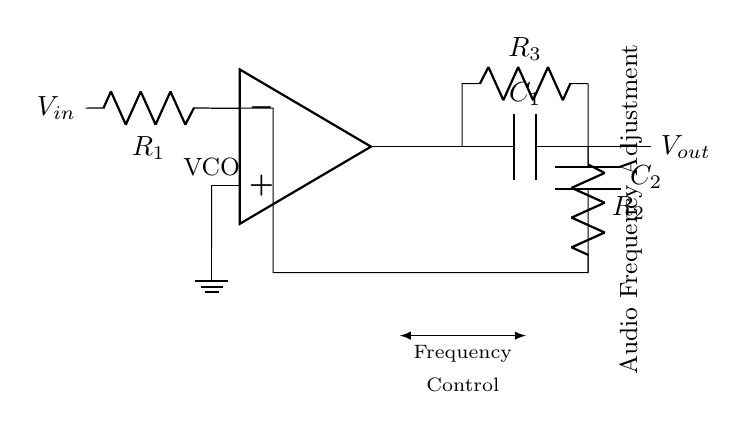What is the type of operational amplifier used in the circuit? The circuit uses an operational amplifier, indicated by the symbol in the diagram labeled as "VCO." These symbols denote the amplification characteristics needed for generating oscillations.
Answer: Operational amplifier What does the component labeled C1 represent? C1 in the diagram is a capacitor, as indicated by the "C" label next to it. Capacitors are critical in timing applications and frequency control circuits such as oscillators.
Answer: Capacitor How many resistors are present in the circuit? By counting the labeled resistors (R1, R2, R3), we see there are three resistors in total, each playing a role in defining the frequency and gain of the oscillator circuit.
Answer: Three What role does R2 play in the feedback loop? R2 is part of the feedback loop, connected from the output back to the inverting input of the op-amp. This feedback is essential in determining the oscillation frequency and stability of the oscillator.
Answer: Feedback What is the purpose of the C2 component in this circuit? C2, another capacitor, is used in conjunction with R3 in the circuit to establish the frequency of oscillation. The combination of C2 with R3 will determine the charging and discharging time, which affects the frequency.
Answer: Frequency control What is the significance of the voltage labeled Vin? Vin is the input voltage to the circuit, which will influence the overall behavior and output frequency of the oscillator. The variable input voltage is essential in voltage-controlled oscillators as it adjusts the output frequency based on its value.
Answer: Input voltage Which section of the circuit illustrates audio frequency adjustment? The label on the right side of the circuit ("Audio Frequency Adjustment") indicates that this section is specifically designed for adjusting audio frequencies, marking the relevant components involved in this function.
Answer: Section with R3 and C2 